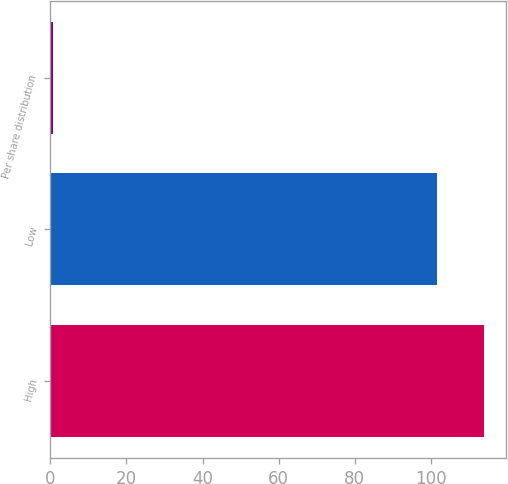<chart> <loc_0><loc_0><loc_500><loc_500><bar_chart><fcel>High<fcel>Low<fcel>Per share distribution<nl><fcel>114.02<fcel>101.51<fcel>0.83<nl></chart> 